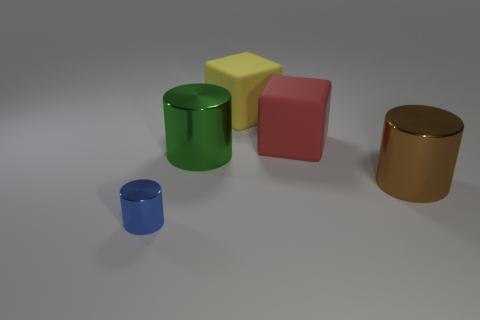Add 4 brown cylinders. How many objects exist? 9 Subtract all cylinders. How many objects are left? 2 Subtract all green shiny things. Subtract all yellow matte cubes. How many objects are left? 3 Add 3 small cylinders. How many small cylinders are left? 4 Add 2 blue shiny spheres. How many blue shiny spheres exist? 2 Subtract 0 red balls. How many objects are left? 5 